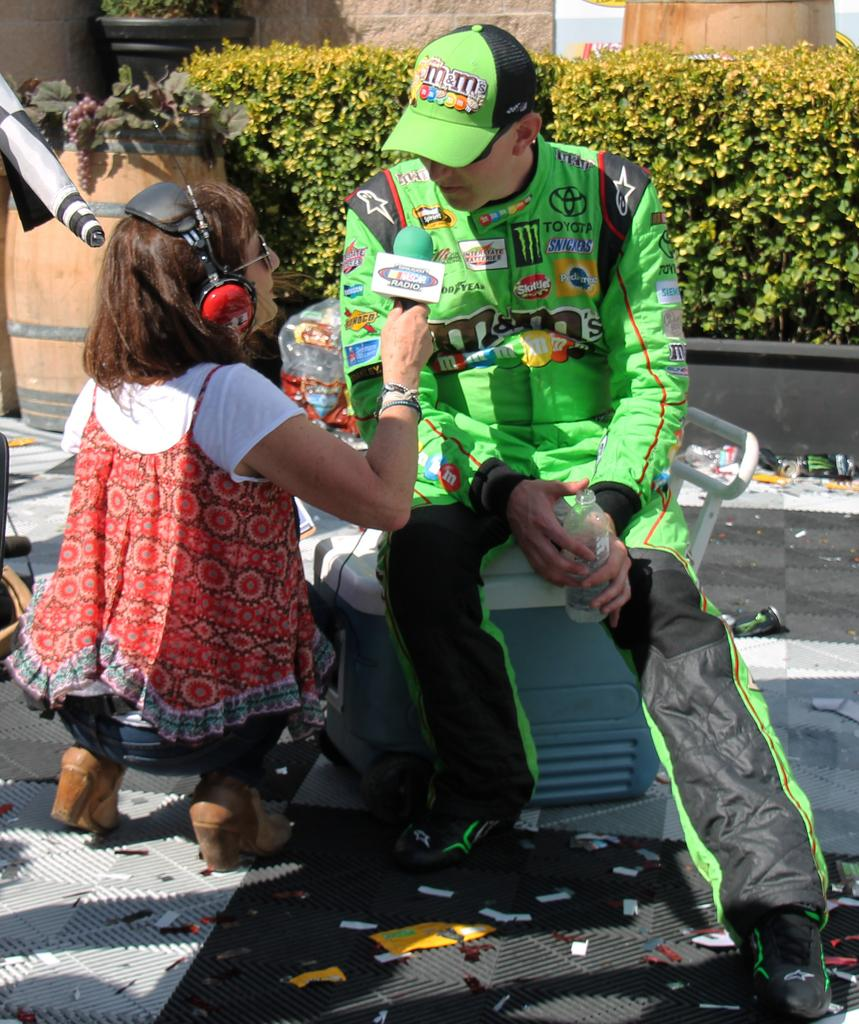What is the woman in the image doing? The woman is sitting on the road and holding a mic. Who else is present in the image? There is a man in a green jersey and green cap in the image. How are the man and woman positioned in relation to each other? The man is in front of the woman. What can be seen in the background of the image? There are plants visible in the image, and they are in front of a building. How many sisters does the woman in the image have? There is no information about the woman's sisters in the image. What sense is being stimulated by the street in the image? The image does not provide information about which sense is being stimulated by the street. 